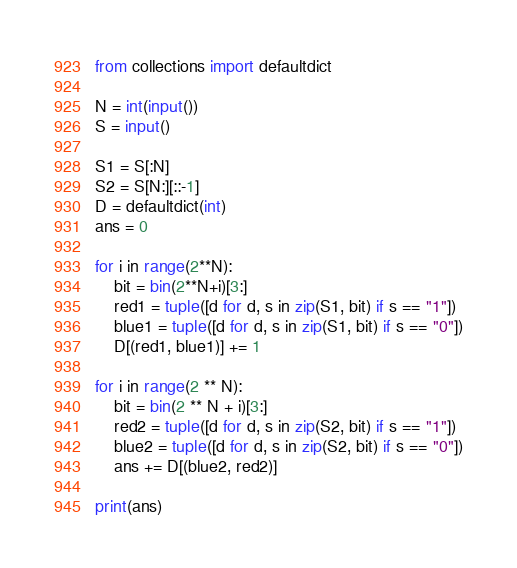Convert code to text. <code><loc_0><loc_0><loc_500><loc_500><_Python_>from collections import defaultdict

N = int(input())
S = input()

S1 = S[:N]
S2 = S[N:][::-1]
D = defaultdict(int)
ans = 0

for i in range(2**N):
    bit = bin(2**N+i)[3:]
    red1 = tuple([d for d, s in zip(S1, bit) if s == "1"])
    blue1 = tuple([d for d, s in zip(S1, bit) if s == "0"])
    D[(red1, blue1)] += 1

for i in range(2 ** N):
    bit = bin(2 ** N + i)[3:]
    red2 = tuple([d for d, s in zip(S2, bit) if s == "1"])
    blue2 = tuple([d for d, s in zip(S2, bit) if s == "0"])
    ans += D[(blue2, red2)]

print(ans)
</code> 